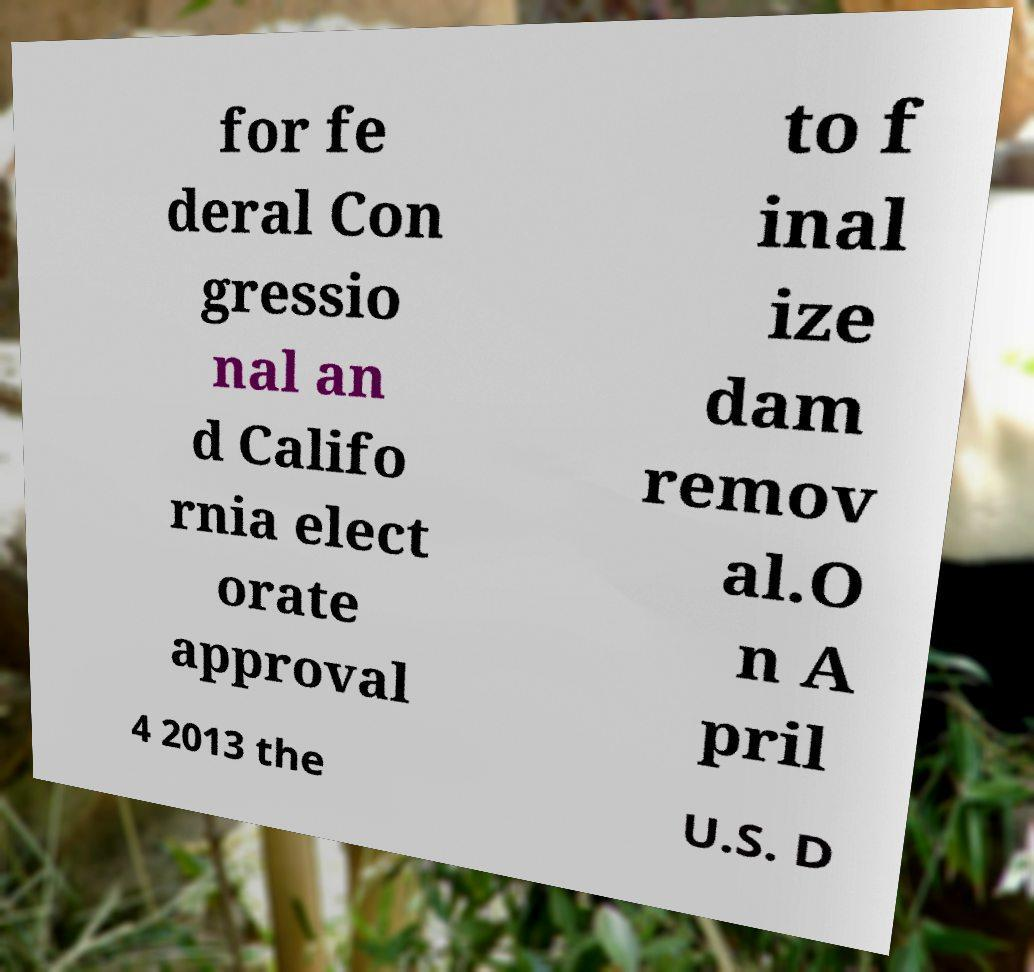For documentation purposes, I need the text within this image transcribed. Could you provide that? for fe deral Con gressio nal an d Califo rnia elect orate approval to f inal ize dam remov al.O n A pril 4 2013 the U.S. D 